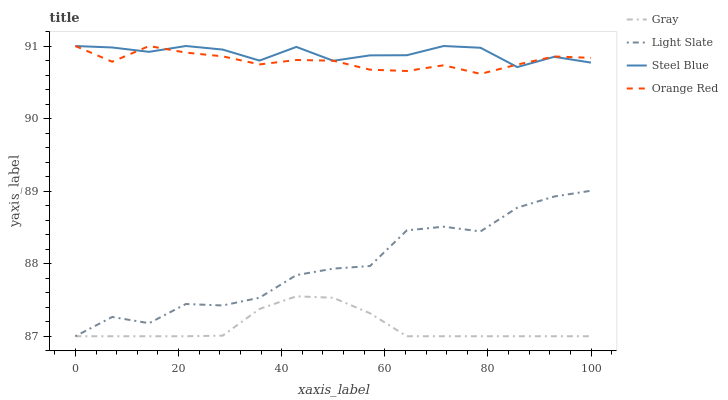Does Gray have the minimum area under the curve?
Answer yes or no. Yes. Does Steel Blue have the maximum area under the curve?
Answer yes or no. Yes. Does Steel Blue have the minimum area under the curve?
Answer yes or no. No. Does Gray have the maximum area under the curve?
Answer yes or no. No. Is Gray the smoothest?
Answer yes or no. Yes. Is Light Slate the roughest?
Answer yes or no. Yes. Is Steel Blue the smoothest?
Answer yes or no. No. Is Steel Blue the roughest?
Answer yes or no. No. Does Light Slate have the lowest value?
Answer yes or no. Yes. Does Steel Blue have the lowest value?
Answer yes or no. No. Does Orange Red have the highest value?
Answer yes or no. Yes. Does Gray have the highest value?
Answer yes or no. No. Is Light Slate less than Steel Blue?
Answer yes or no. Yes. Is Orange Red greater than Gray?
Answer yes or no. Yes. Does Light Slate intersect Gray?
Answer yes or no. Yes. Is Light Slate less than Gray?
Answer yes or no. No. Is Light Slate greater than Gray?
Answer yes or no. No. Does Light Slate intersect Steel Blue?
Answer yes or no. No. 